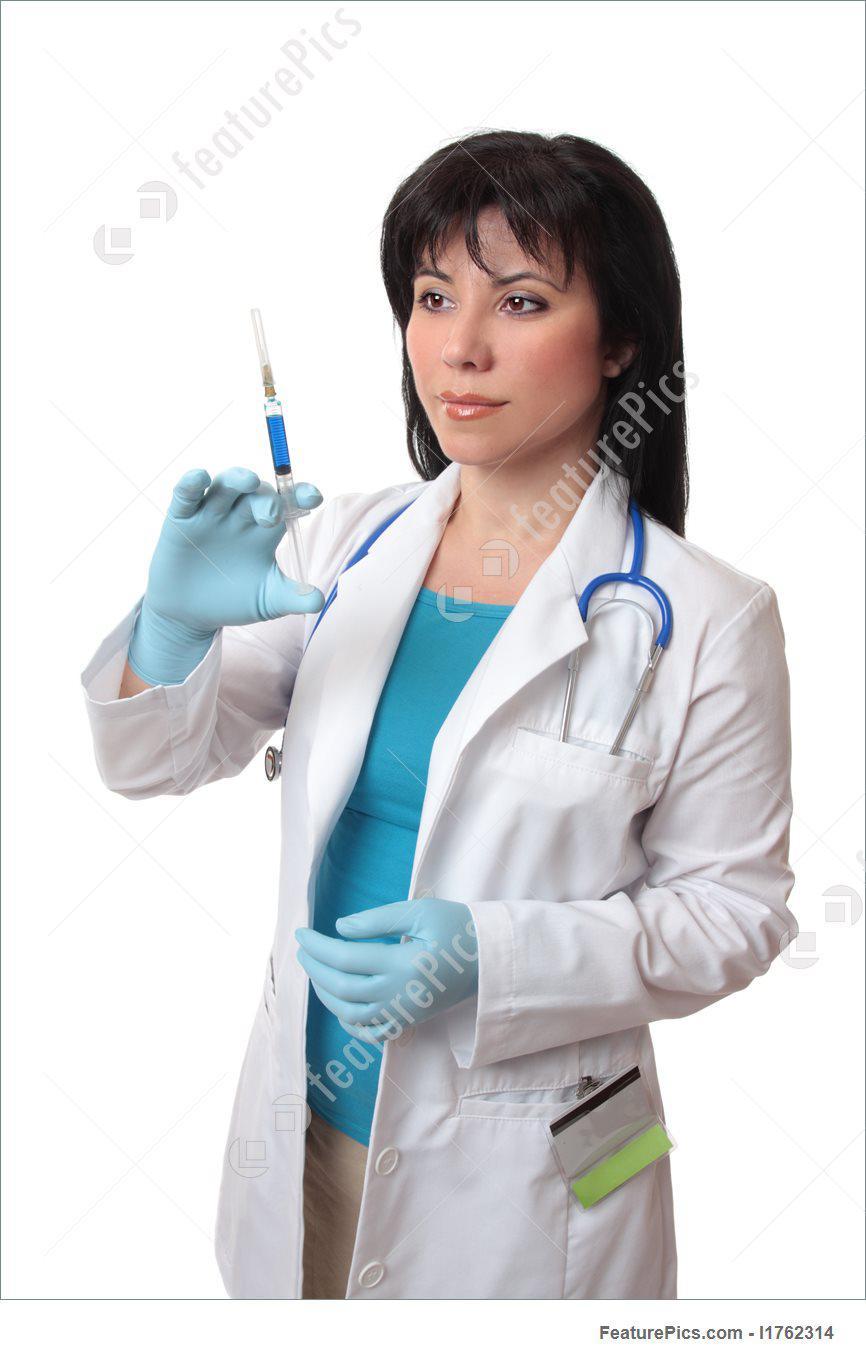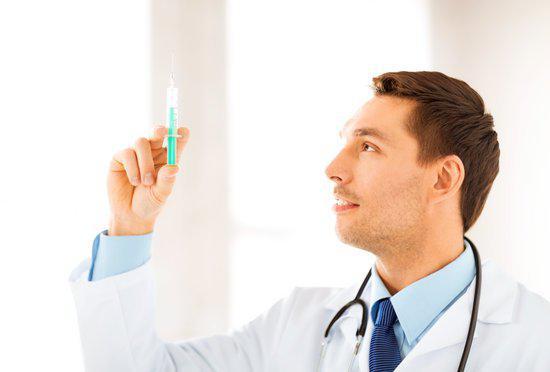The first image is the image on the left, the second image is the image on the right. Assess this claim about the two images: "Two women are holding syringes.". Correct or not? Answer yes or no. No. The first image is the image on the left, the second image is the image on the right. Assess this claim about the two images: "There are two women holding needles.". Correct or not? Answer yes or no. No. 